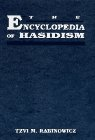What is the title of this book? The book is titled 'The Encyclopedia of Hasidism.' It is an in-depth resource covering various aspects of Hasidic Judaism, including its history, culture, and religious practices. 